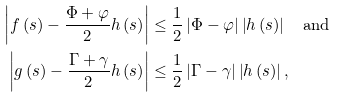<formula> <loc_0><loc_0><loc_500><loc_500>\left | f \left ( s \right ) - \frac { \Phi + \varphi } { 2 } h \left ( s \right ) \right | & \leq \frac { 1 } { 2 } \left | \Phi - \varphi \right | \left | h \left ( s \right ) \right | \text { \ \ and} \\ \left | g \left ( s \right ) - \frac { \Gamma + \gamma } { 2 } h \left ( s \right ) \right | & \leq \frac { 1 } { 2 } \left | \Gamma - \gamma \right | \left | h \left ( s \right ) \right | ,</formula> 